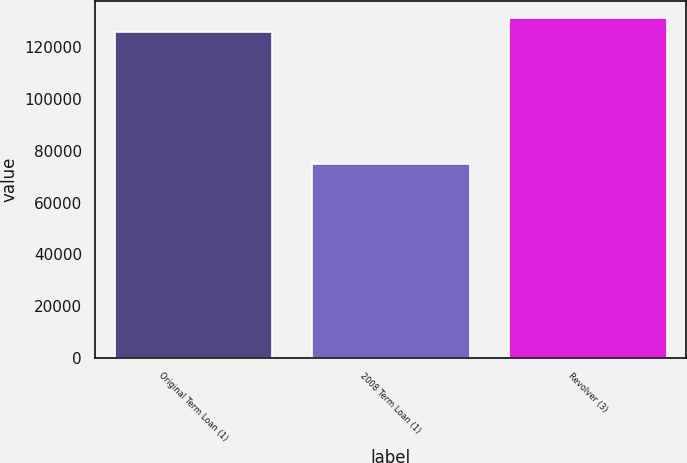Convert chart to OTSL. <chart><loc_0><loc_0><loc_500><loc_500><bar_chart><fcel>Original Term Loan (1)<fcel>2008 Term Loan (1)<fcel>Revolver (3)<nl><fcel>126000<fcel>75000<fcel>131300<nl></chart> 